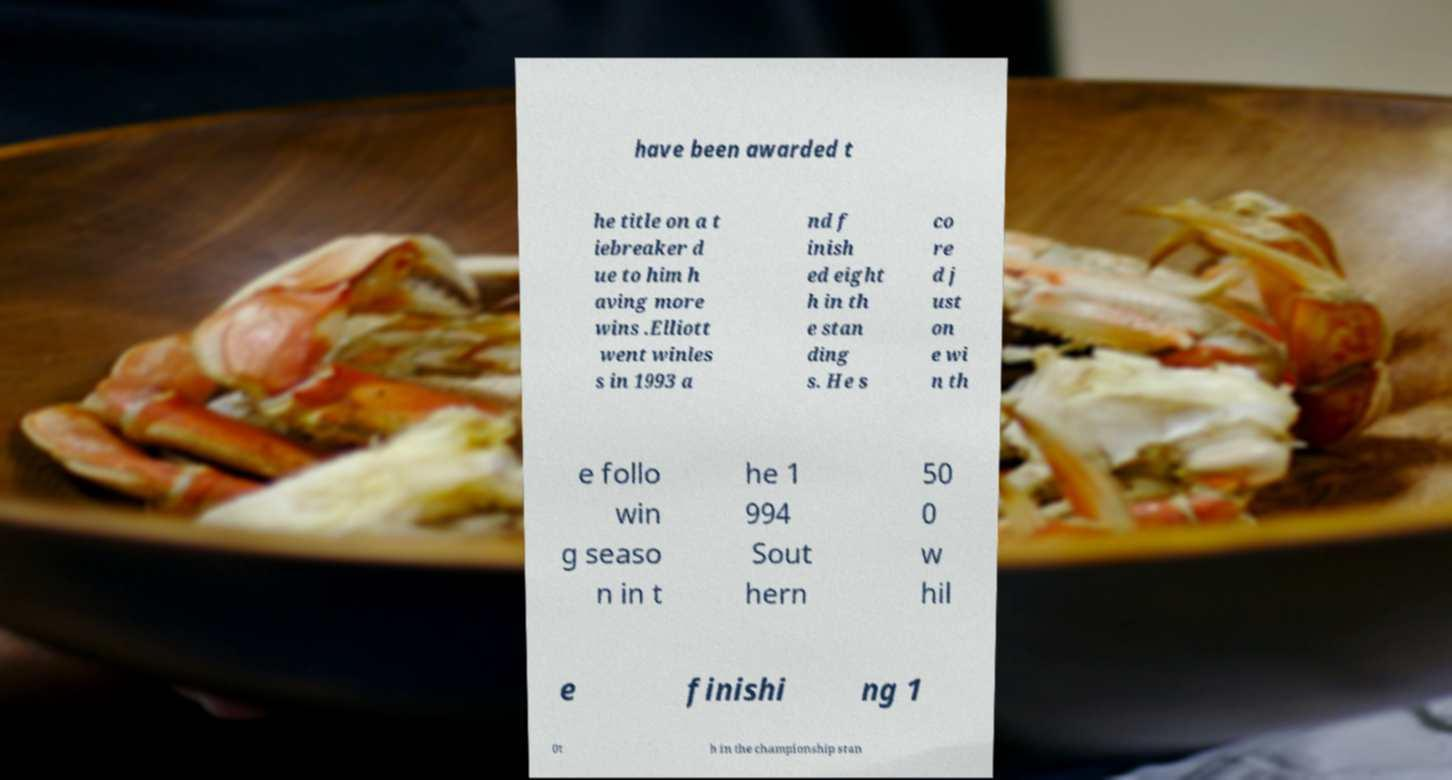Could you extract and type out the text from this image? have been awarded t he title on a t iebreaker d ue to him h aving more wins .Elliott went winles s in 1993 a nd f inish ed eight h in th e stan ding s. He s co re d j ust on e wi n th e follo win g seaso n in t he 1 994 Sout hern 50 0 w hil e finishi ng 1 0t h in the championship stan 